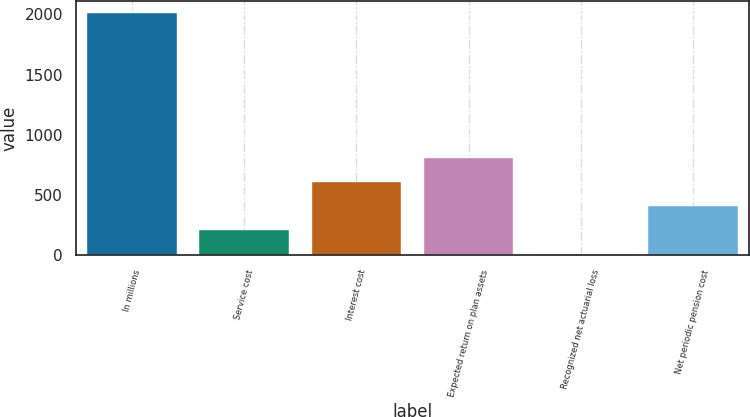Convert chart to OTSL. <chart><loc_0><loc_0><loc_500><loc_500><bar_chart><fcel>In millions<fcel>Service cost<fcel>Interest cost<fcel>Expected return on plan assets<fcel>Recognized net actuarial loss<fcel>Net periodic pension cost<nl><fcel>2011<fcel>213.7<fcel>613.1<fcel>812.8<fcel>14<fcel>413.4<nl></chart> 